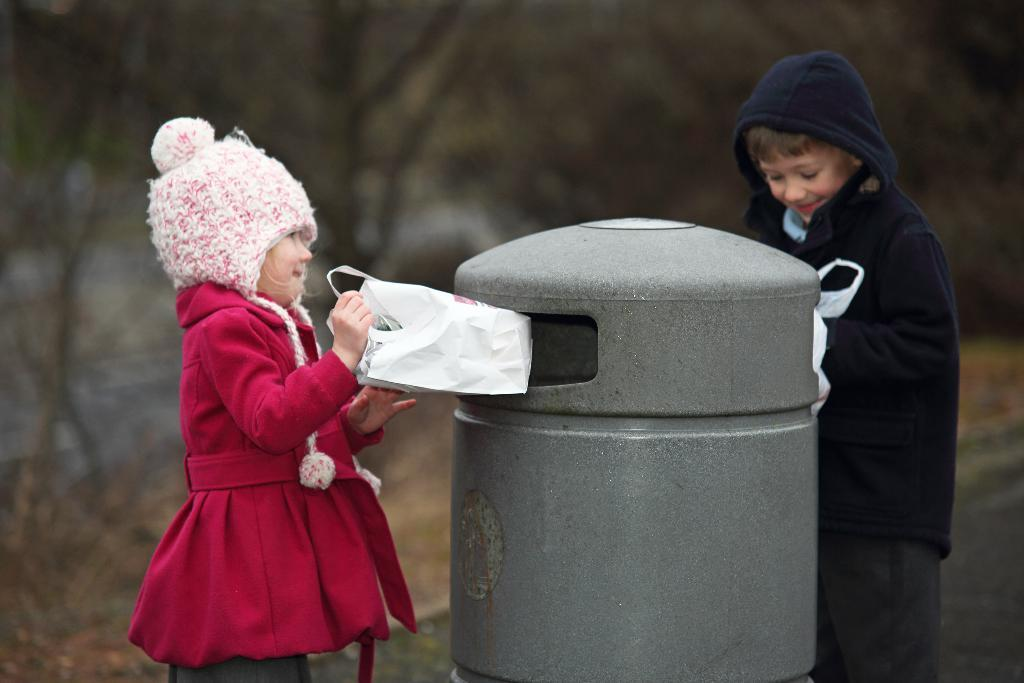How many children are present in the image? There are 2 children standing in the image. What are the children holding in their hands? The children are holding polythene covers. Can you describe the object between the children? There is a cylindrical object between the children. What can be observed about the background of the image? The background of the image is blurred. What type of brick is being used as a guide for the children in the image? There is no brick present in the image, nor is there any indication that a guide is being used. 